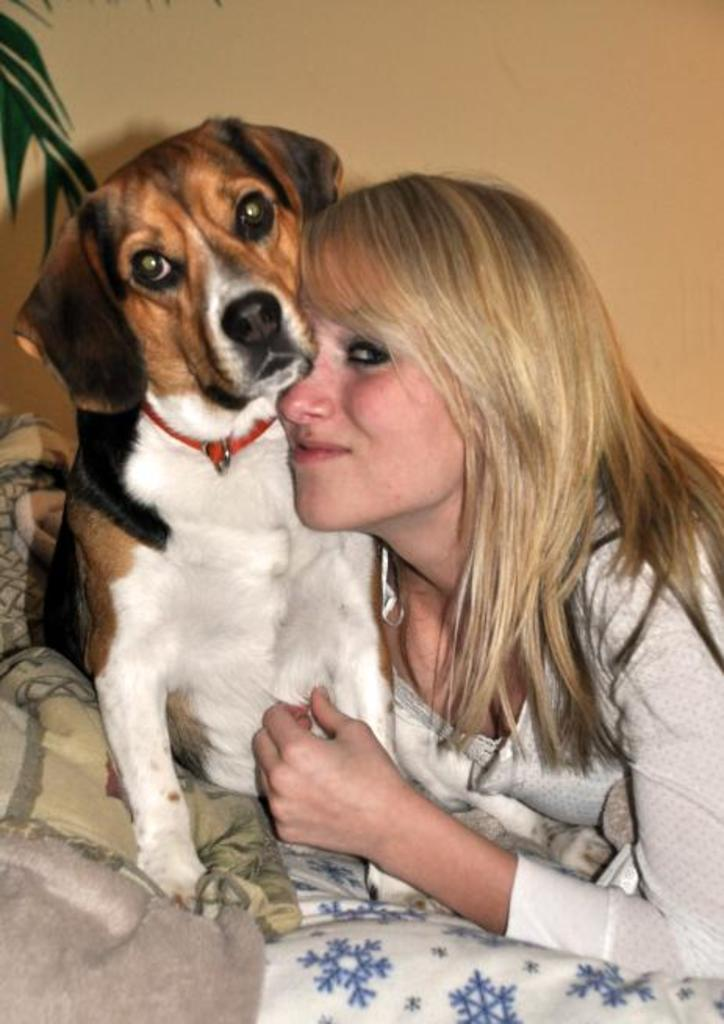Who is present in the image? There is a woman in the image. What is the woman holding? The woman is holding a dog. How is the dog dressed or covered in the image? The dog is wrapped in a fur blanket. What type of leather is the cow wearing in the image? There is no cow or leather present in the image. Who is the woman's friend in the image? The provided facts do not mention any friends or other people in the image. 